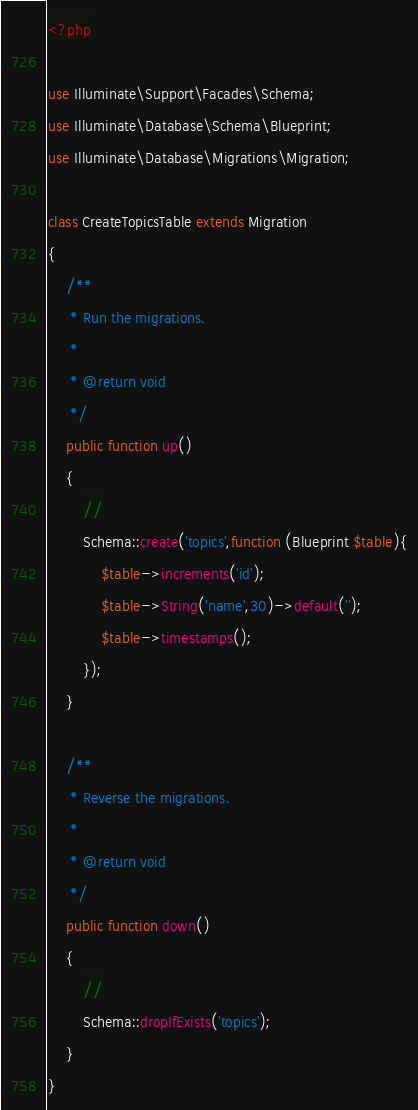<code> <loc_0><loc_0><loc_500><loc_500><_PHP_><?php

use Illuminate\Support\Facades\Schema;
use Illuminate\Database\Schema\Blueprint;
use Illuminate\Database\Migrations\Migration;

class CreateTopicsTable extends Migration
{
    /**
     * Run the migrations.
     *
     * @return void
     */
    public function up()
    {
        //
        Schema::create('topics',function (Blueprint $table){
            $table->increments('id');
            $table->String('name',30)->default('');
            $table->timestamps();
        });
    }

    /**
     * Reverse the migrations.
     *
     * @return void
     */
    public function down()
    {
        //
        Schema::dropIfExists('topics');
    }
}
</code> 